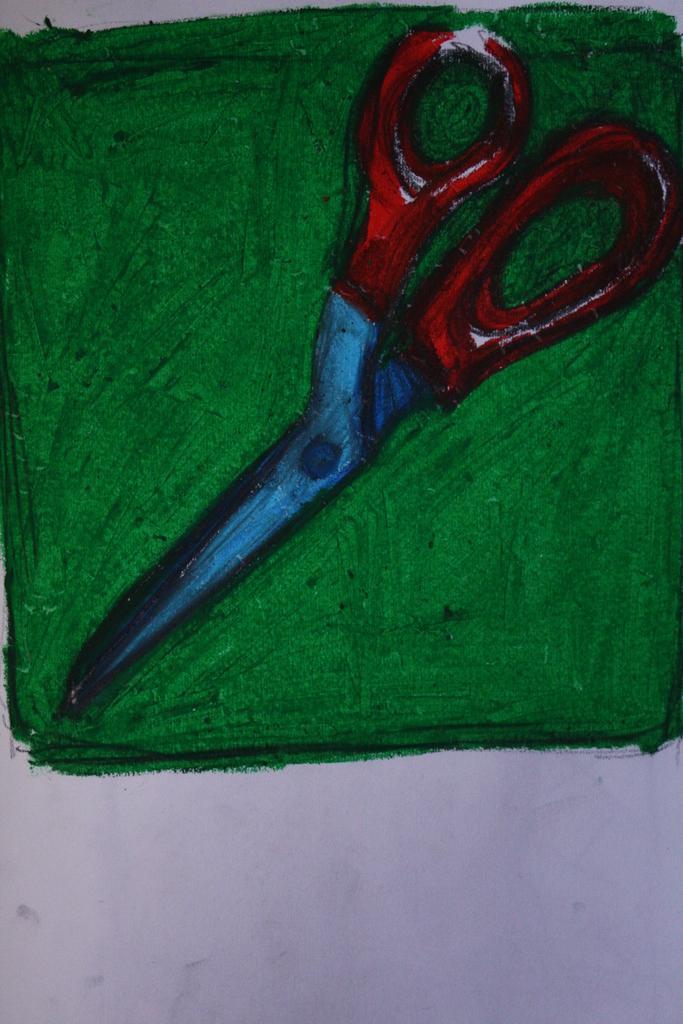Describe this image in one or two sentences. It's a painting of a scissor and this is in green color. 